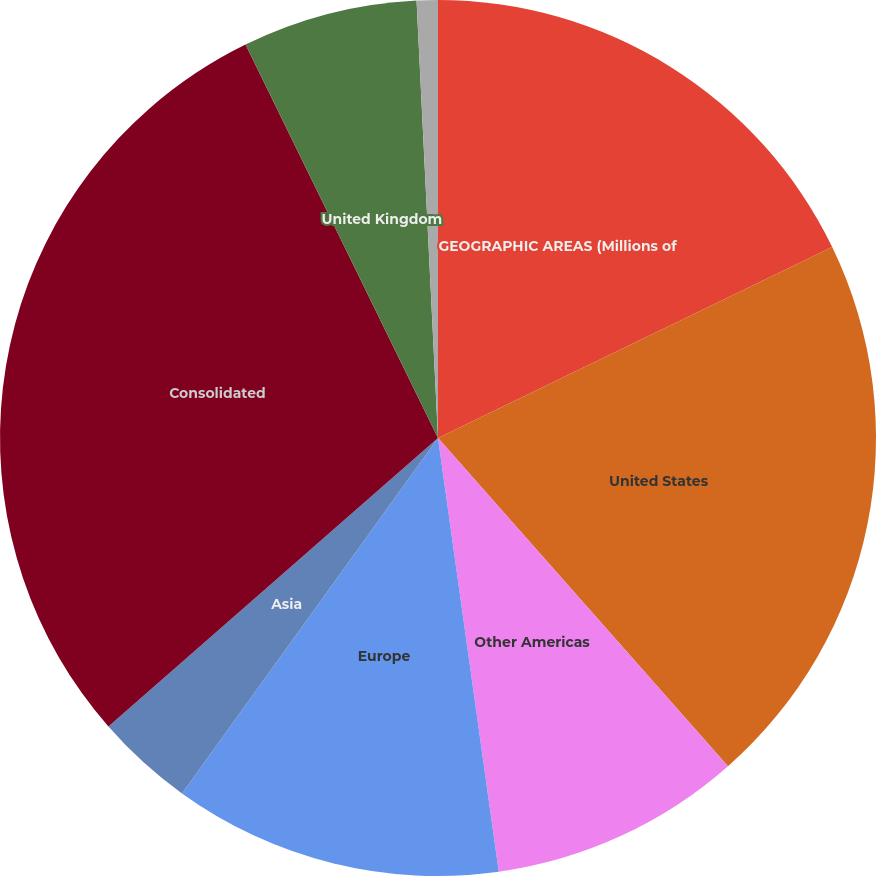Convert chart. <chart><loc_0><loc_0><loc_500><loc_500><pie_chart><fcel>GEOGRAPHIC AREAS (Millions of<fcel>United States<fcel>Other Americas<fcel>Europe<fcel>Asia<fcel>Consolidated<fcel>United Kingdom<fcel>Other Europe<nl><fcel>17.82%<fcel>20.66%<fcel>9.3%<fcel>12.15%<fcel>3.62%<fcel>29.2%<fcel>6.46%<fcel>0.78%<nl></chart> 